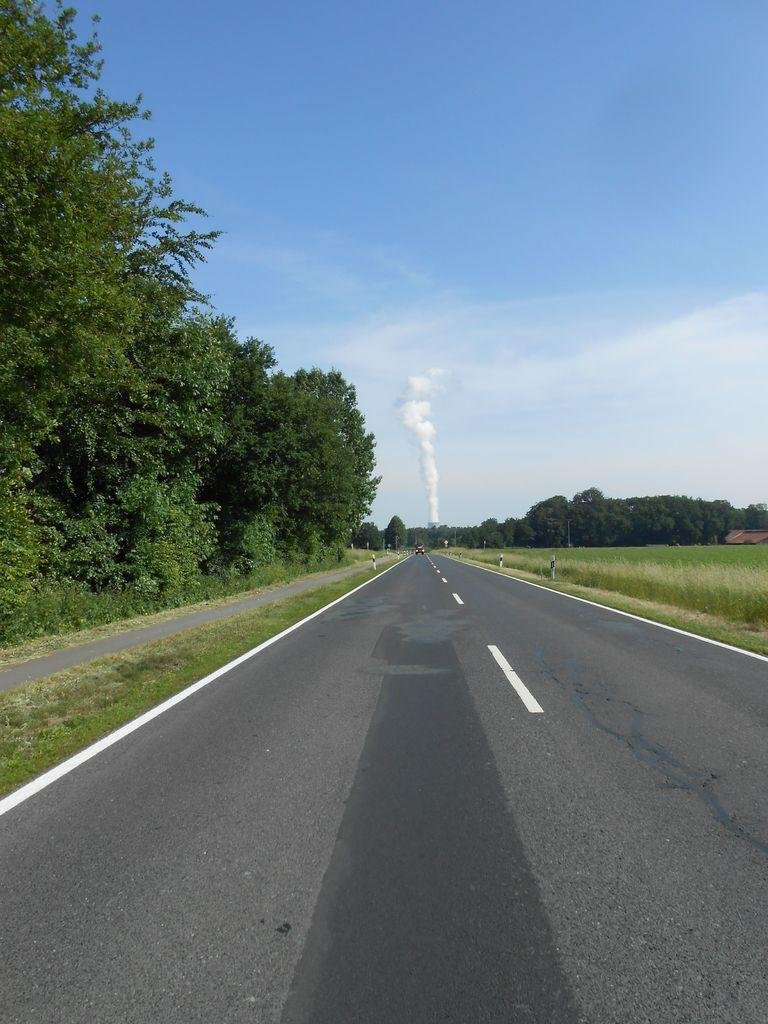What is the main feature of the image? There is a road in the image. What can be seen at the top of the image? The sky is visible at the top of the image. What type of vegetation is present in the middle of the image? There are trees and grass in the middle of the image. Can you tell me how many tigers are walking on the tray in the image? There are no tigers or trays present in the image. What type of attack is being carried out by the trees in the image? There is no attack being carried out by the trees in the image; they are simply standing in the middle of the image. 